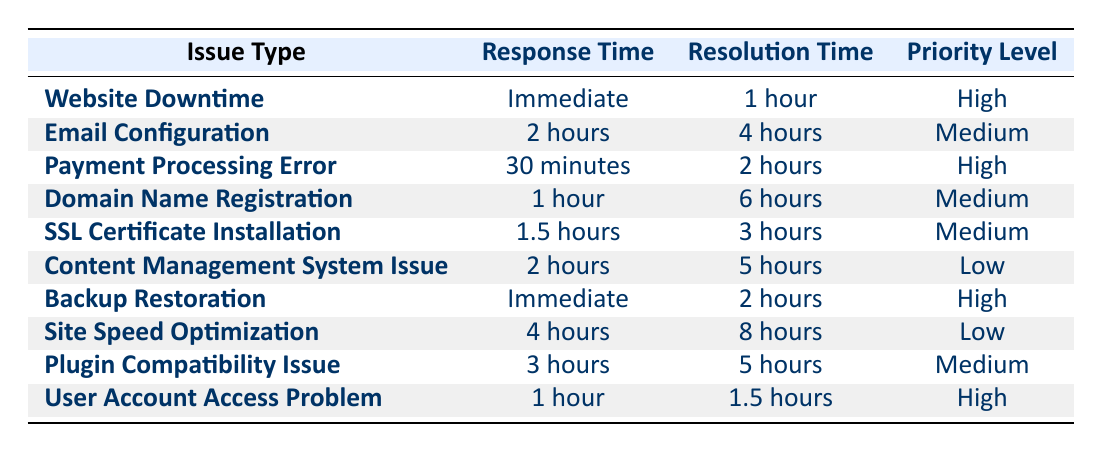What is the response time for a Website Downtime issue? The table lists the response time for a Website Downtime issue under the "Response Time" column. It shows "Immediate."
Answer: Immediate What is the resolution time for the Backup Restoration issue? By locating the "Backup Restoration" row in the table, the resolution time under the "Resolution Time" column is "2 hours."
Answer: 2 hours Is the priority level for Email Configuration issue Medium? Checking the "Email Configuration" row, the priority level is indeed shown as "Medium."
Answer: Yes How much longer does it take to resolve a Site Speed Optimization issue compared to a User Account Access Problem? For Site Speed Optimization, the resolution time is "8 hours," and for User Account Access Problem, it is "1.5 hours." The difference is calculated as 8 - 1.5 = 6.5 hours.
Answer: 6.5 hours Which issue type has the longest response time? By inspecting the "Response Time" column, Site Speed Optimization has the longest response time listed as "4 hours."
Answer: 4 hours What is the average resolution time for Medium priority issues? The Medium priority issues are Email Configuration (4 hours), Domain Name Registration (6 hours), SSL Certificate Installation (3 hours), and Plugin Compatibility Issue (5 hours). The sum is 4 + 6 + 3 + 5 = 18 hours, divided by 4 gives an average of 4.5 hours.
Answer: 4.5 hours Are there more High priority issues than Low priority issues in the table? Counting the issues, there are 4 High priority issues (Website Downtime, Payment Processing Error, Backup Restoration, User Account Access Problem) and 2 Low priority issues (Content Management System Issue, Site Speed Optimization). Therefore, there are more High priority issues.
Answer: Yes What is the maximum response time for any issue type? Looking over the response times listed in the table, the longest time noted is "4 hours" for the Site Speed Optimization.
Answer: 4 hours 